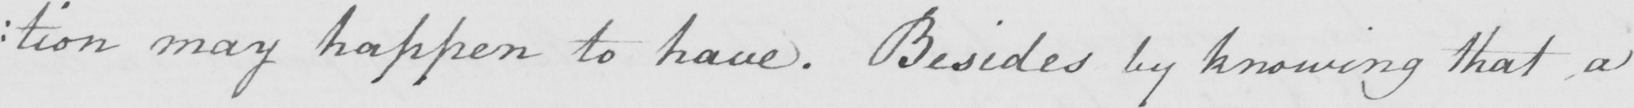What is written in this line of handwriting? : tion may happen to have . Besides by knowing that a 